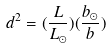Convert formula to latex. <formula><loc_0><loc_0><loc_500><loc_500>d ^ { 2 } = ( \frac { L } { L _ { \odot } } ) ( \frac { b _ { \odot } } { b } )</formula> 